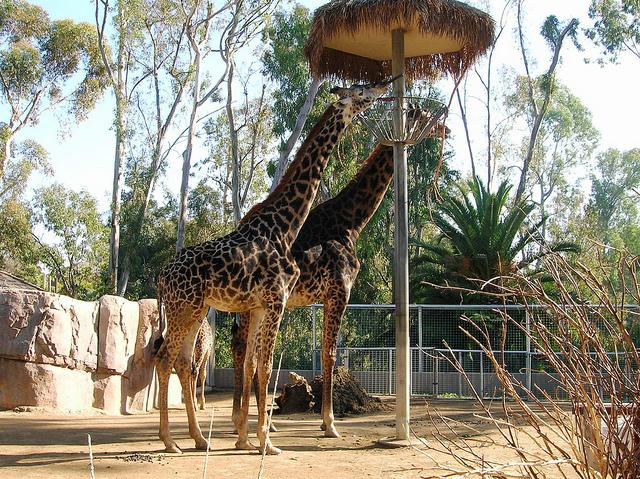What kind of animals are shown?
Give a very brief answer. Giraffes. Are the giraffes in their wild habitat?
Answer briefly. No. How many giraffes are here?
Answer briefly. 2. How many giraffe are walking by the wall?
Quick response, please. 2. 